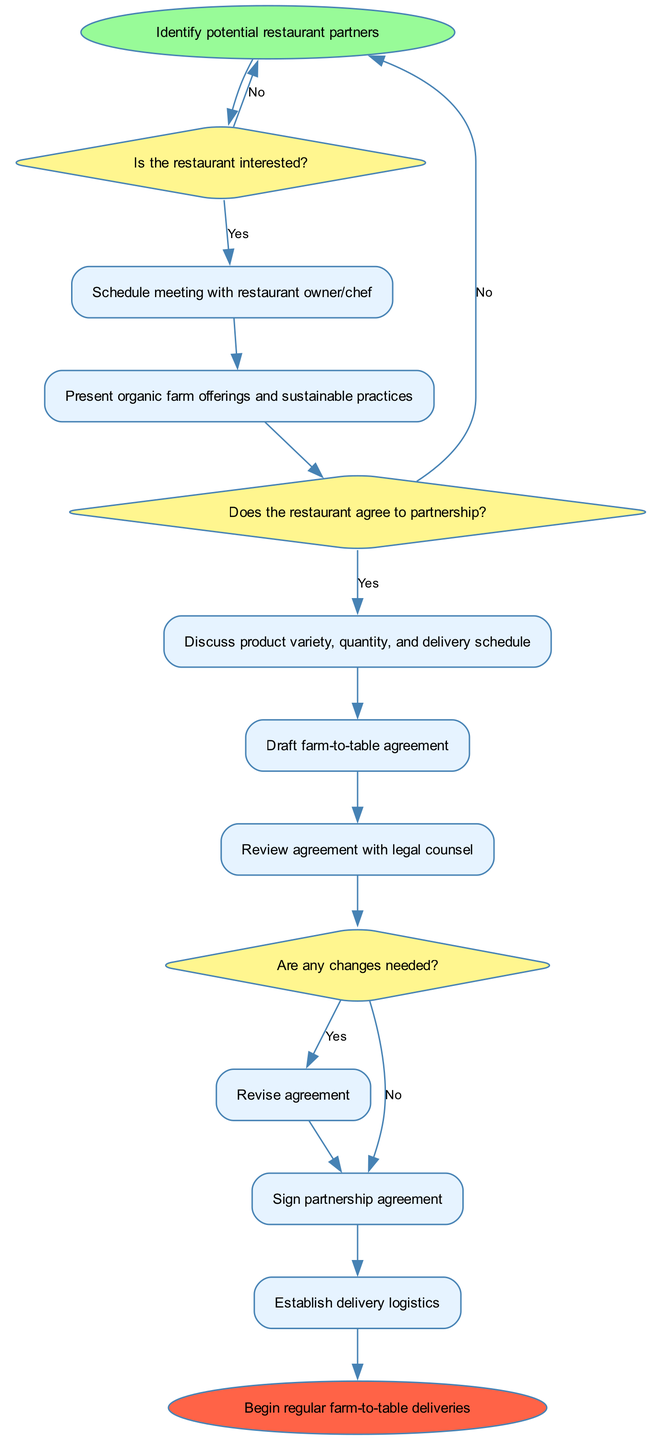What is the first step in the procedure? The diagram indicates that the first step is to "Identify potential restaurant partners." This is evident as it is the starting point of the flow chart.
Answer: Identify potential restaurant partners How many decision nodes are in the diagram? By analyzing the diagram, there are three decision nodes labeled "decision1," "decision2," and "decision3." Each node represents a point in the process where a choice is made.
Answer: 3 What happens if the restaurant is not interested? Following the diagram, if the restaurant is not interested at decision1, the flow returns to the start node, indicating that potential partners need to be identified again.
Answer: Return to start What processes follow after the restaurant owner/chef meeting? After the meeting with the restaurant owner/chef, the subsequent process is to "Present organic farm offerings and sustainable practices." This is the direct next step according to the flow of the diagram.
Answer: Present organic farm offerings and sustainable practices What occurs before the partnership agreement is signed? The process before signing the partnership agreement is "Review agreement with legal counsel." This step is necessary to ensure that the terms are appropriate and legally sound before finalizing the partnership.
Answer: Review agreement with legal counsel What should be done if changes are needed for the agreement? If changes are needed, the flow diagram indicates to "Revise agreement." This step is crucial to incorporate any modifications before moving forward with the partnership.
Answer: Revise agreement What is the final step in the process? The final step in the process is to "Begin regular farm-to-table deliveries," signifying the outcome of successfully establishing the partnership.
Answer: Begin regular farm-to-table deliveries 